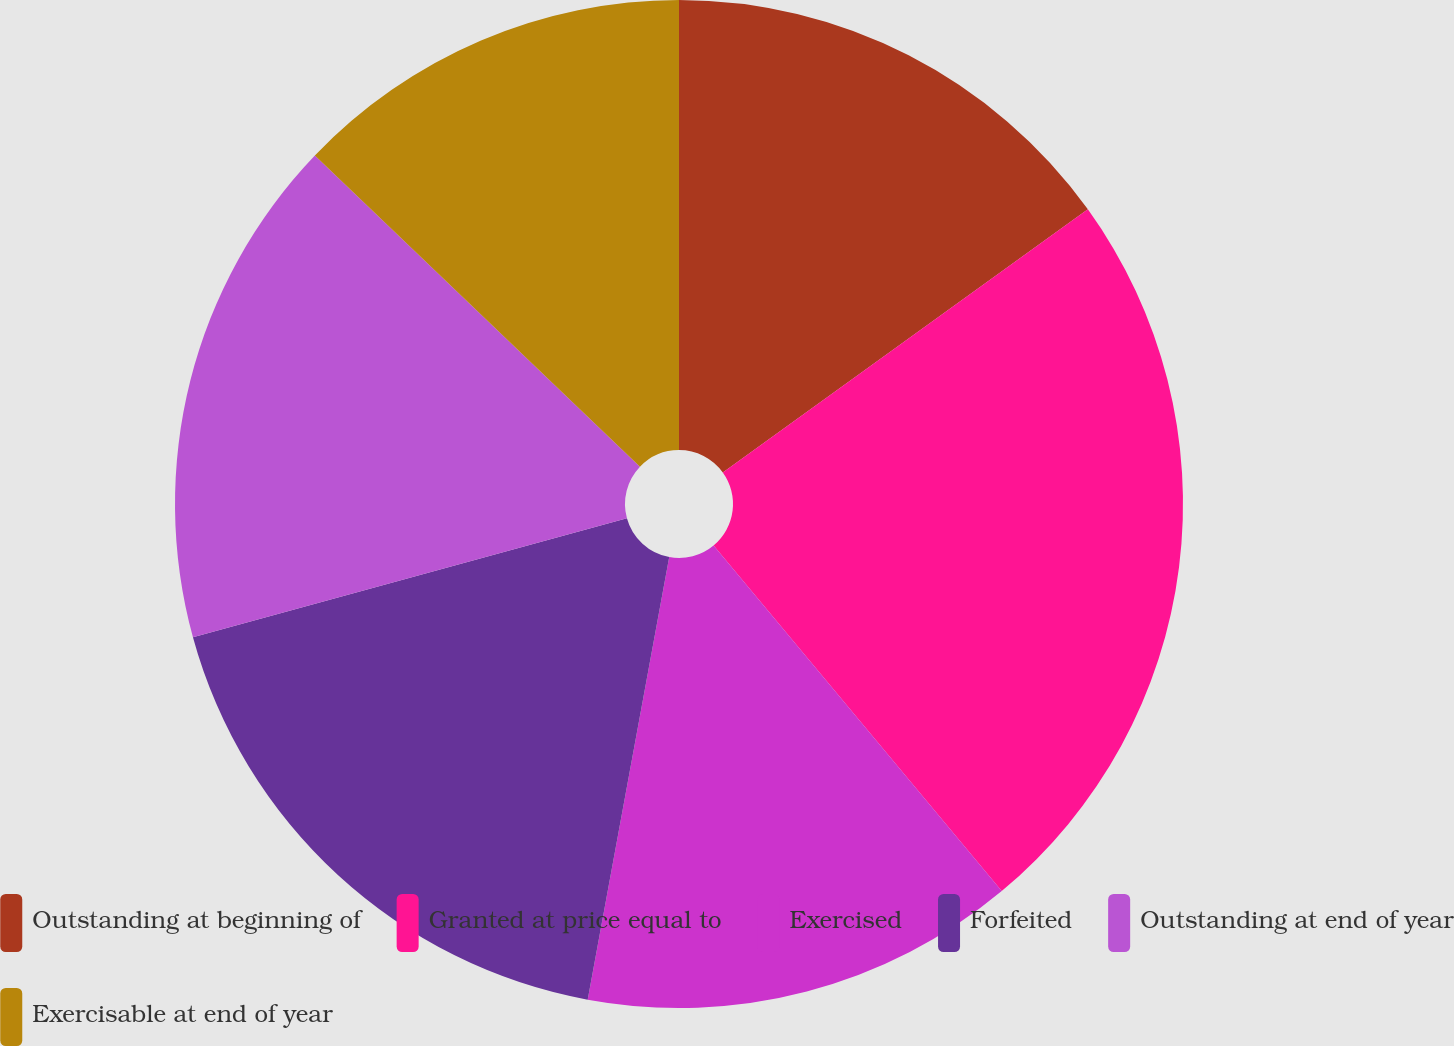Convert chart to OTSL. <chart><loc_0><loc_0><loc_500><loc_500><pie_chart><fcel>Outstanding at beginning of<fcel>Granted at price equal to<fcel>Exercised<fcel>Forfeited<fcel>Outstanding at end of year<fcel>Exercisable at end of year<nl><fcel>15.06%<fcel>23.88%<fcel>13.96%<fcel>17.84%<fcel>16.41%<fcel>12.85%<nl></chart> 